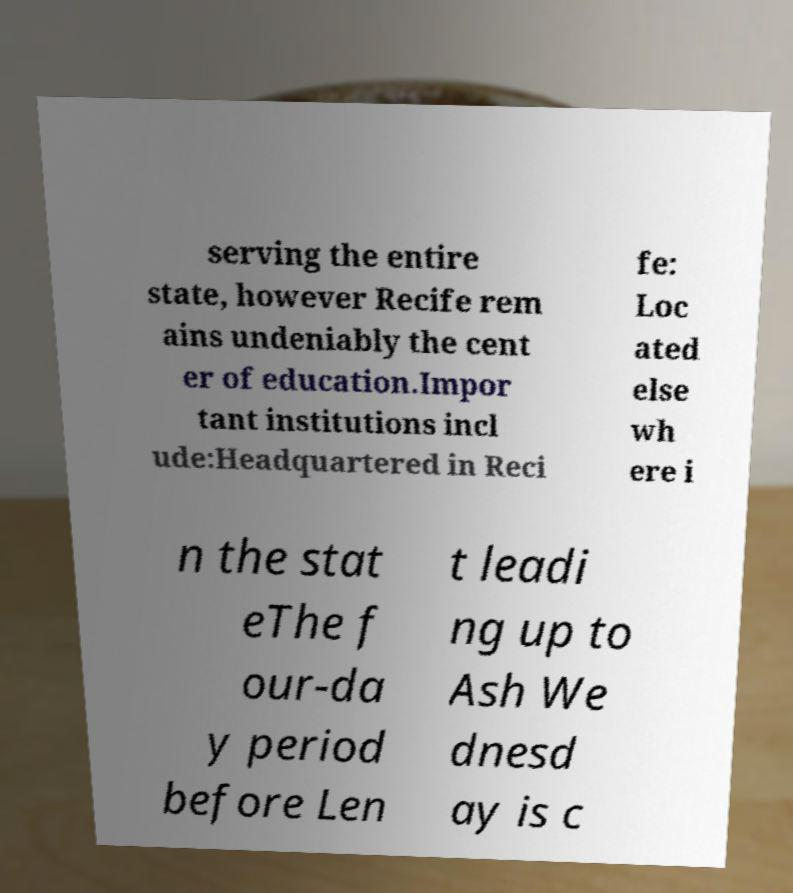Could you extract and type out the text from this image? serving the entire state, however Recife rem ains undeniably the cent er of education.Impor tant institutions incl ude:Headquartered in Reci fe: Loc ated else wh ere i n the stat eThe f our-da y period before Len t leadi ng up to Ash We dnesd ay is c 